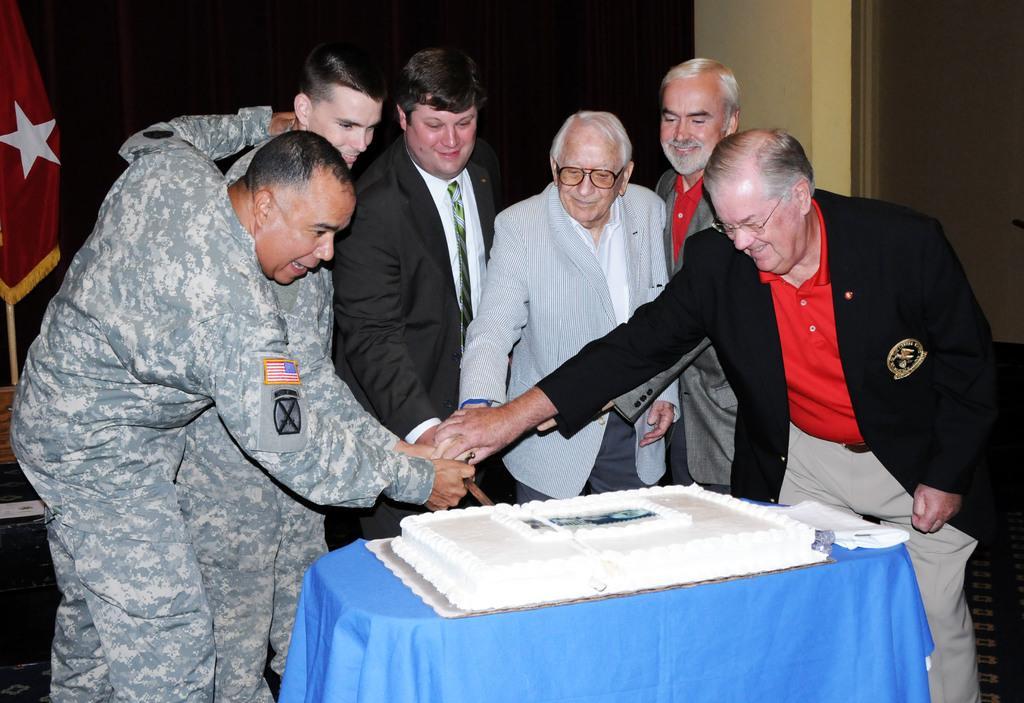Please provide a concise description of this image. In this image there are a group of people who are holding knife and cutting the cake, in front of them there is a table. On the table there is one cake and beside the cake there are some papers, and in the background there is a wall and flag and some objects. 